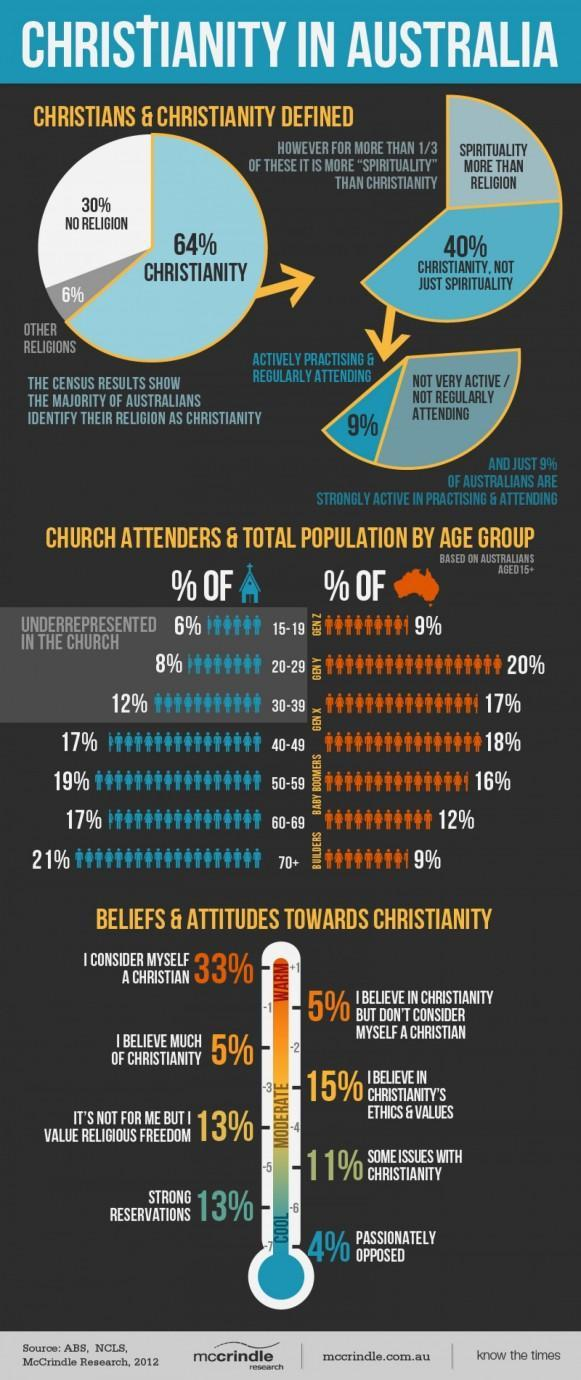What percentage of Christians in Australia are not very active and not following christian traditions?
Answer the question with a short phrase. 31 What percentage of people in Australia are not Christians? 36 What percentage of christian people in Australia are more of Spiritual rather than Christian? 24 Which is the major category of people in Australia after Christians? No Religion Which is the age group that is lowest among the population and the highest percentage in attending mass? 70+ In which mode of the thermometer image highest no of Christians are concentrated? Warm Into how many different modes Christian people attitudes, beliefs are divided? 3 What percentage of people in Australia are real Christians out of all Christians? 40% Which are the different modes into which Christian people attitudes, beliefs are divided? Cool, Moderate, Warm What percentage of Christians in Australia are actually following Christian traditions in their daily life? 9% 